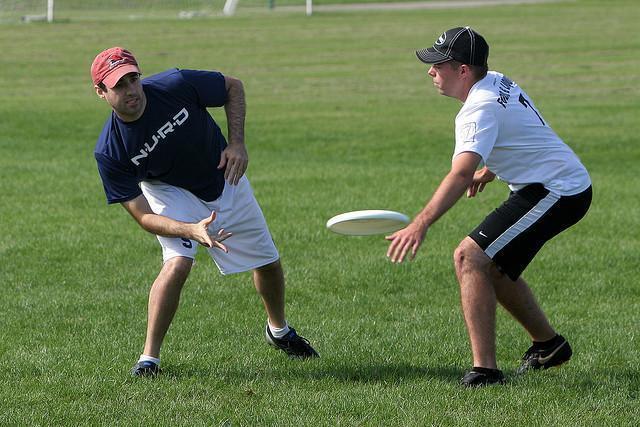How many people are there?
Give a very brief answer. 2. 